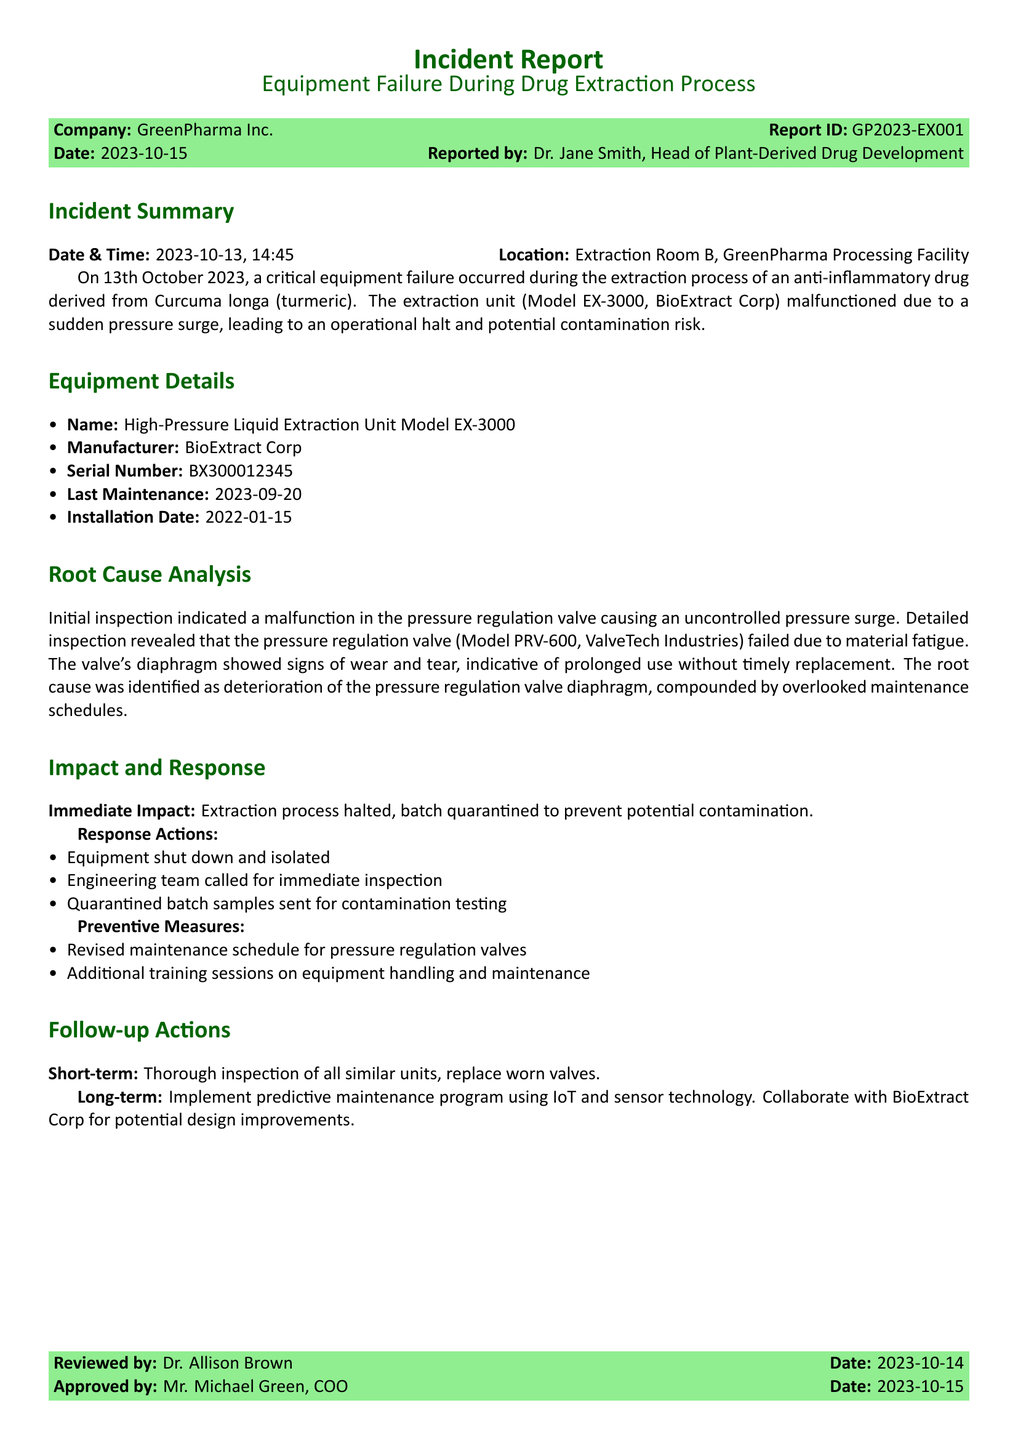what is the report ID? The report ID is listed in the incident report section, specifically under the company name and date.
Answer: GP2023-EX001 who reported the incident? The individual's name is provided in the report, specifying who the report was submitted by.
Answer: Dr. Jane Smith what was the equipment model involved in the failure? The equipment model is mentioned in the Equipment Details section, identifying the specific model related to the incident.
Answer: EX-3000 when was the last maintenance performed? This information is found in the Equipment Details section, detailing the last time the equipment was serviced.
Answer: 2023-09-20 what was the immediate impact of the incident? The report details the immediate consequence of the equipment failure, which is highlighted in the Impact and Response section.
Answer: Extraction process halted what caused the equipment failure? The root cause of the failure is identified in the Root Cause Analysis section, explaining the factors leading to the issue.
Answer: Deterioration of the pressure regulation valve diaphragm what preventive measures were taken? The report specifies actions to prevent future incidents, providing insights into the steps being implemented post-incident.
Answer: Revised maintenance schedule for pressure regulation valves how long had the equipment been installed? The installation date is provided in the Equipment Details section, which can be used to calculate the duration since installation.
Answer: 1 year 9 months what is recommended for long-term actions? The long-term recommendations are discussed in the Follow-up Actions section, focusing on strategies for ongoing improvements.
Answer: Implement predictive maintenance program using IoT and sensor technology 